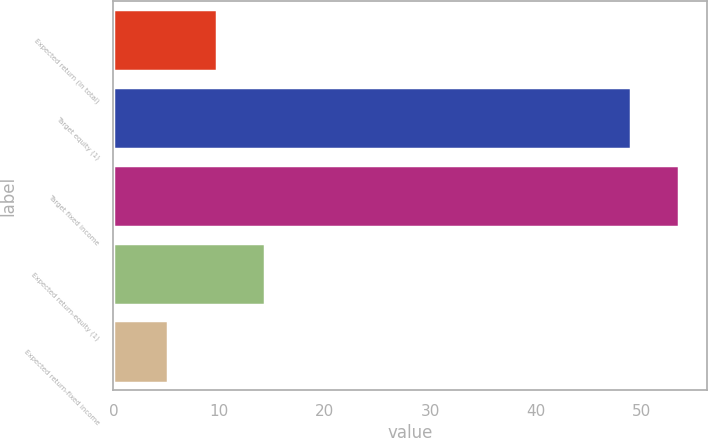Convert chart. <chart><loc_0><loc_0><loc_500><loc_500><bar_chart><fcel>Expected return (in total)<fcel>Target equity (1)<fcel>Target fixed income<fcel>Expected return-equity (1)<fcel>Expected return-fixed income<nl><fcel>9.78<fcel>49<fcel>53.58<fcel>14.36<fcel>5.2<nl></chart> 